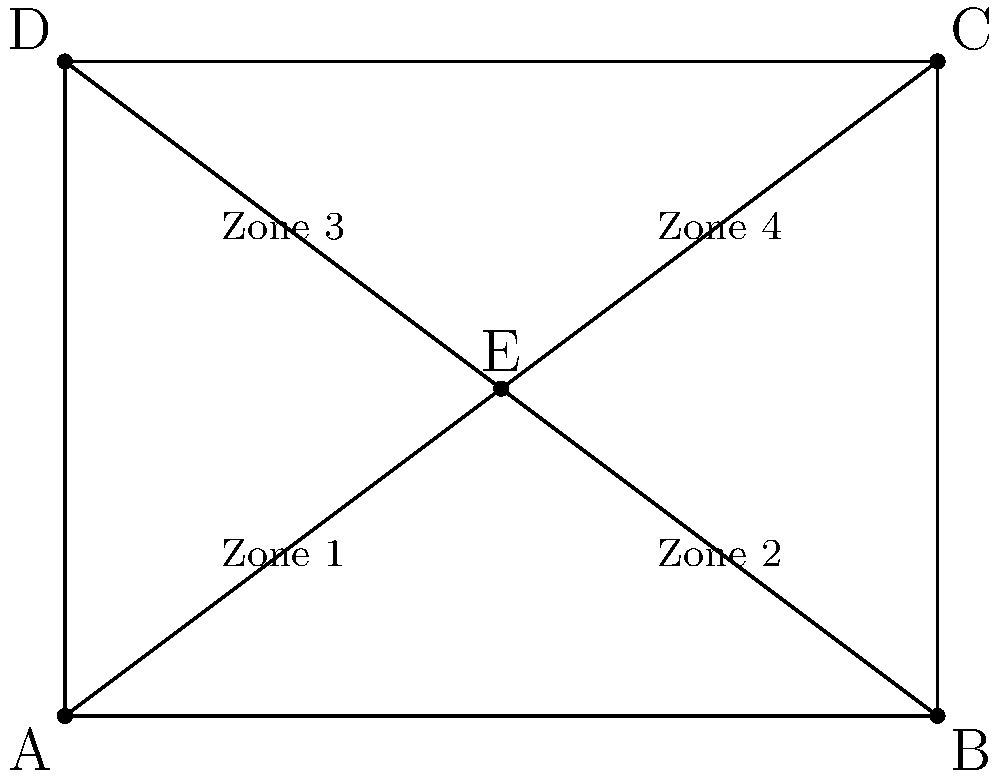In the diagram above, a school playground is divided into four safety zones. If Zone 1 is congruent to Zone 3, and Zone 2 is congruent to Zone 4, what can be concluded about point E? To determine the position of point E, we can follow these steps:

1. Observe that the playground is divided into four zones by the diagonals AC and BD.

2. We are given that Zone 1 is congruent to Zone 3, and Zone 2 is congruent to Zone 4.

3. In a rectangle, diagonals bisect each other. This means that point E, where the diagonals intersect, is the midpoint of both diagonals.

4. Since E is the midpoint of both diagonals, it divides each diagonal into two equal parts.

5. This division of the diagonals into equal parts ensures that:
   - The area of Zone 1 = The area of Zone 3
   - The area of Zone 2 = The area of Zone 4

6. The only point that satisfies these conditions is the center of the rectangle.

Therefore, point E must be located at the center of the rectangular playground, ensuring the congruence of the opposite zones.
Answer: E is the center of the rectangle. 